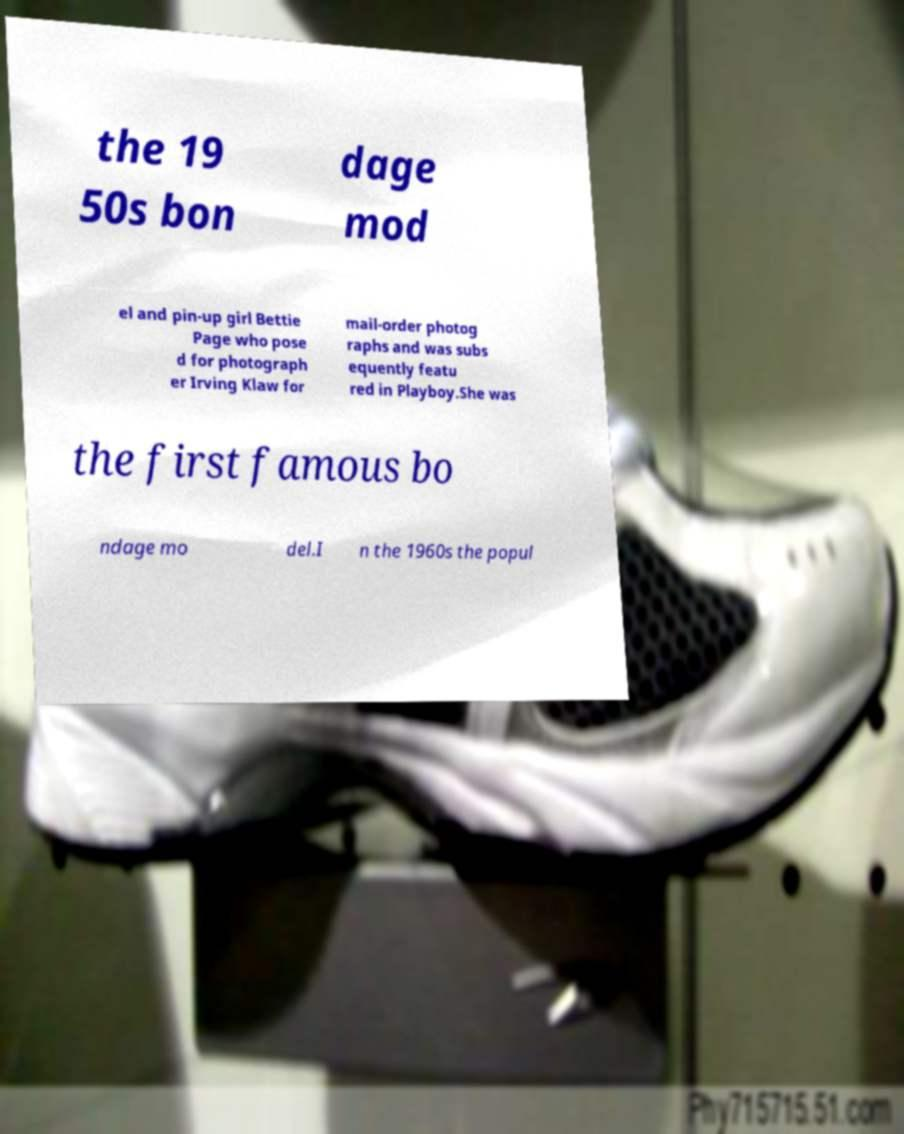Please identify and transcribe the text found in this image. the 19 50s bon dage mod el and pin-up girl Bettie Page who pose d for photograph er Irving Klaw for mail-order photog raphs and was subs equently featu red in Playboy.She was the first famous bo ndage mo del.I n the 1960s the popul 